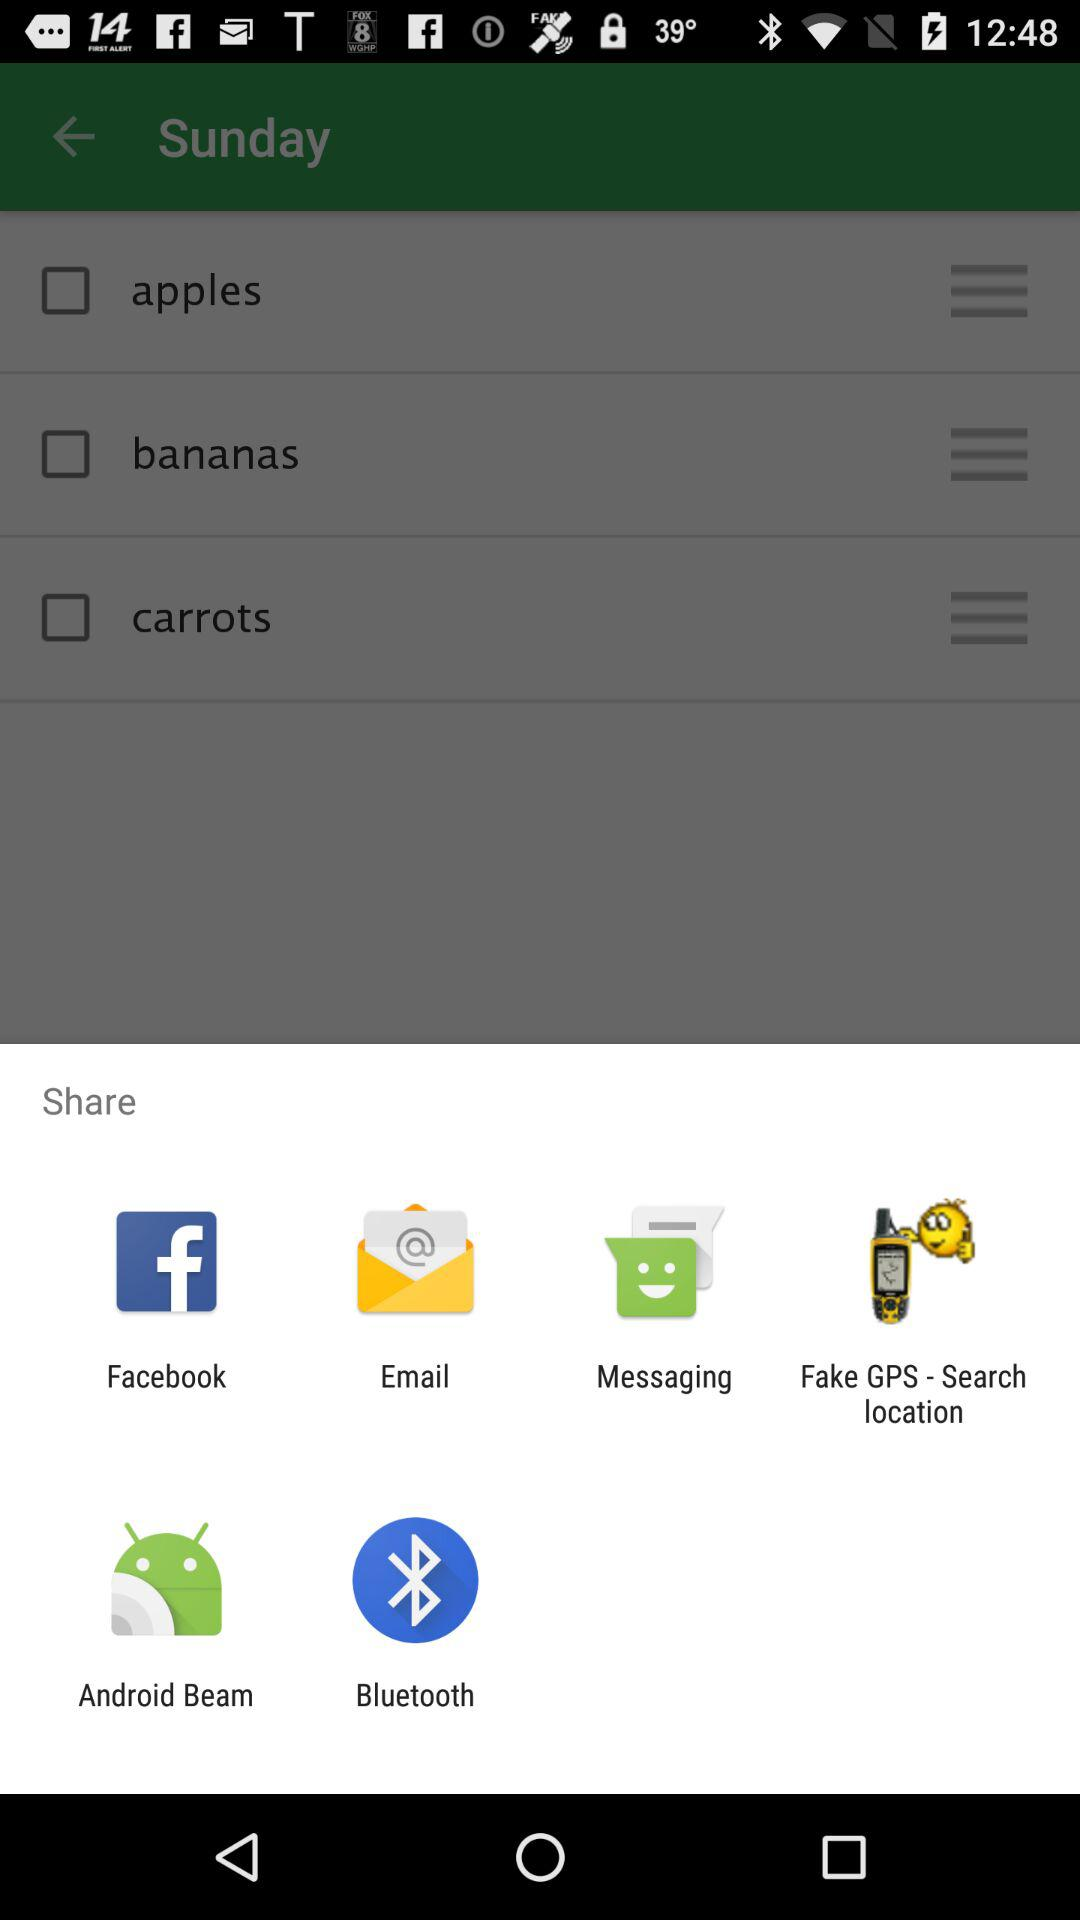Through which app can I share? You can share through "Facebook", "Email", "Messaging", "Fake GPS - Search location", "Android Beam" and "Bluetooth". 